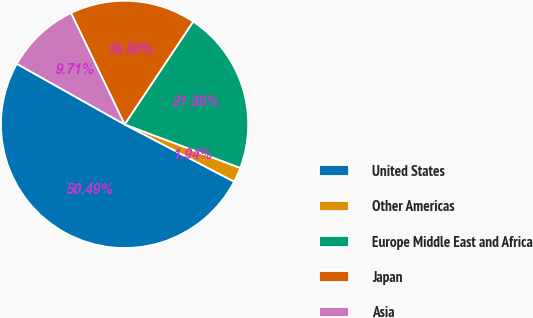<chart> <loc_0><loc_0><loc_500><loc_500><pie_chart><fcel>United States<fcel>Other Americas<fcel>Europe Middle East and Africa<fcel>Japan<fcel>Asia<nl><fcel>50.49%<fcel>1.94%<fcel>21.36%<fcel>16.5%<fcel>9.71%<nl></chart> 